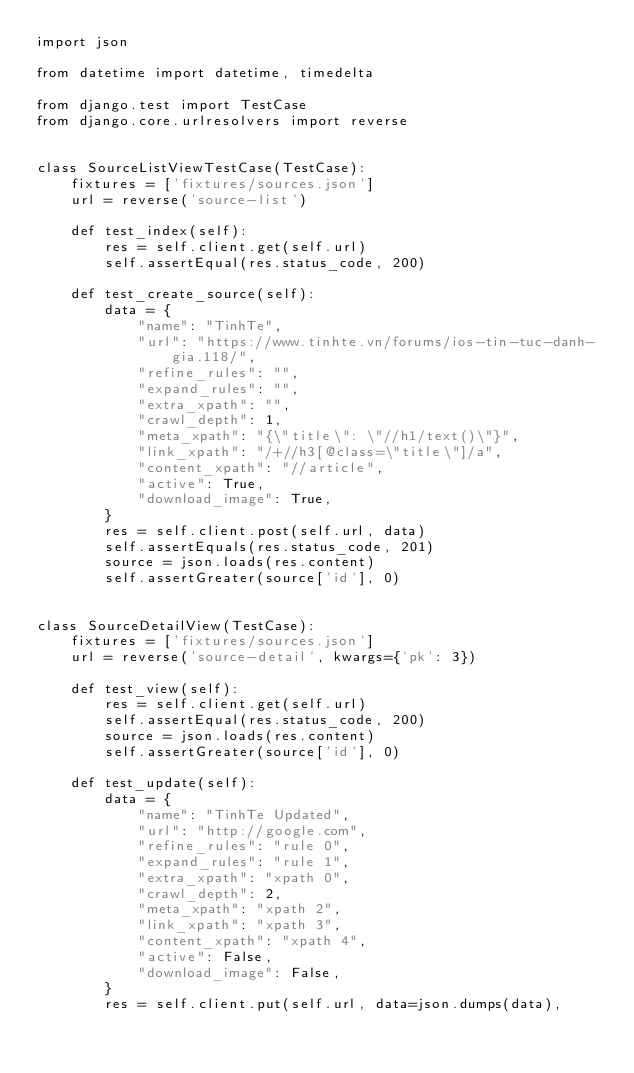Convert code to text. <code><loc_0><loc_0><loc_500><loc_500><_Python_>import json

from datetime import datetime, timedelta

from django.test import TestCase
from django.core.urlresolvers import reverse


class SourceListViewTestCase(TestCase):
    fixtures = ['fixtures/sources.json']
    url = reverse('source-list')

    def test_index(self):
        res = self.client.get(self.url)
        self.assertEqual(res.status_code, 200)

    def test_create_source(self):
        data = {
            "name": "TinhTe",
            "url": "https://www.tinhte.vn/forums/ios-tin-tuc-danh-gia.118/",
            "refine_rules": "",
            "expand_rules": "",
            "extra_xpath": "",
            "crawl_depth": 1,
            "meta_xpath": "{\"title\": \"//h1/text()\"}",
            "link_xpath": "/+//h3[@class=\"title\"]/a",
            "content_xpath": "//article",
            "active": True,
            "download_image": True,
        }
        res = self.client.post(self.url, data)
        self.assertEquals(res.status_code, 201)
        source = json.loads(res.content)
        self.assertGreater(source['id'], 0)


class SourceDetailView(TestCase):
    fixtures = ['fixtures/sources.json']
    url = reverse('source-detail', kwargs={'pk': 3})

    def test_view(self):
        res = self.client.get(self.url)
        self.assertEqual(res.status_code, 200)
        source = json.loads(res.content)
        self.assertGreater(source['id'], 0)

    def test_update(self):
        data = {
            "name": "TinhTe Updated",
            "url": "http://google.com",
            "refine_rules": "rule 0",
            "expand_rules": "rule 1",
            "extra_xpath": "xpath 0",
            "crawl_depth": 2,
            "meta_xpath": "xpath 2",
            "link_xpath": "xpath 3",
            "content_xpath": "xpath 4",
            "active": False,
            "download_image": False,
        }
        res = self.client.put(self.url, data=json.dumps(data),</code> 